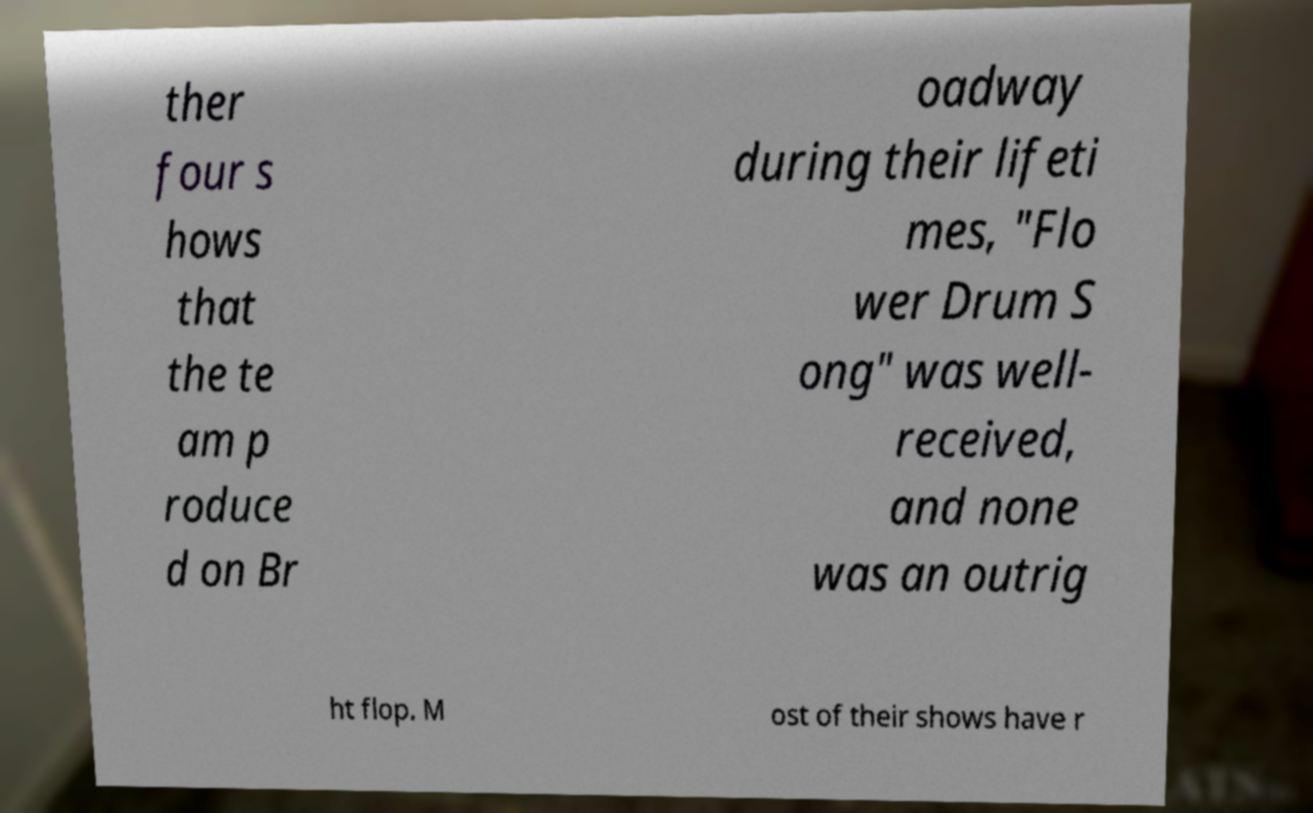Could you assist in decoding the text presented in this image and type it out clearly? ther four s hows that the te am p roduce d on Br oadway during their lifeti mes, "Flo wer Drum S ong" was well- received, and none was an outrig ht flop. M ost of their shows have r 